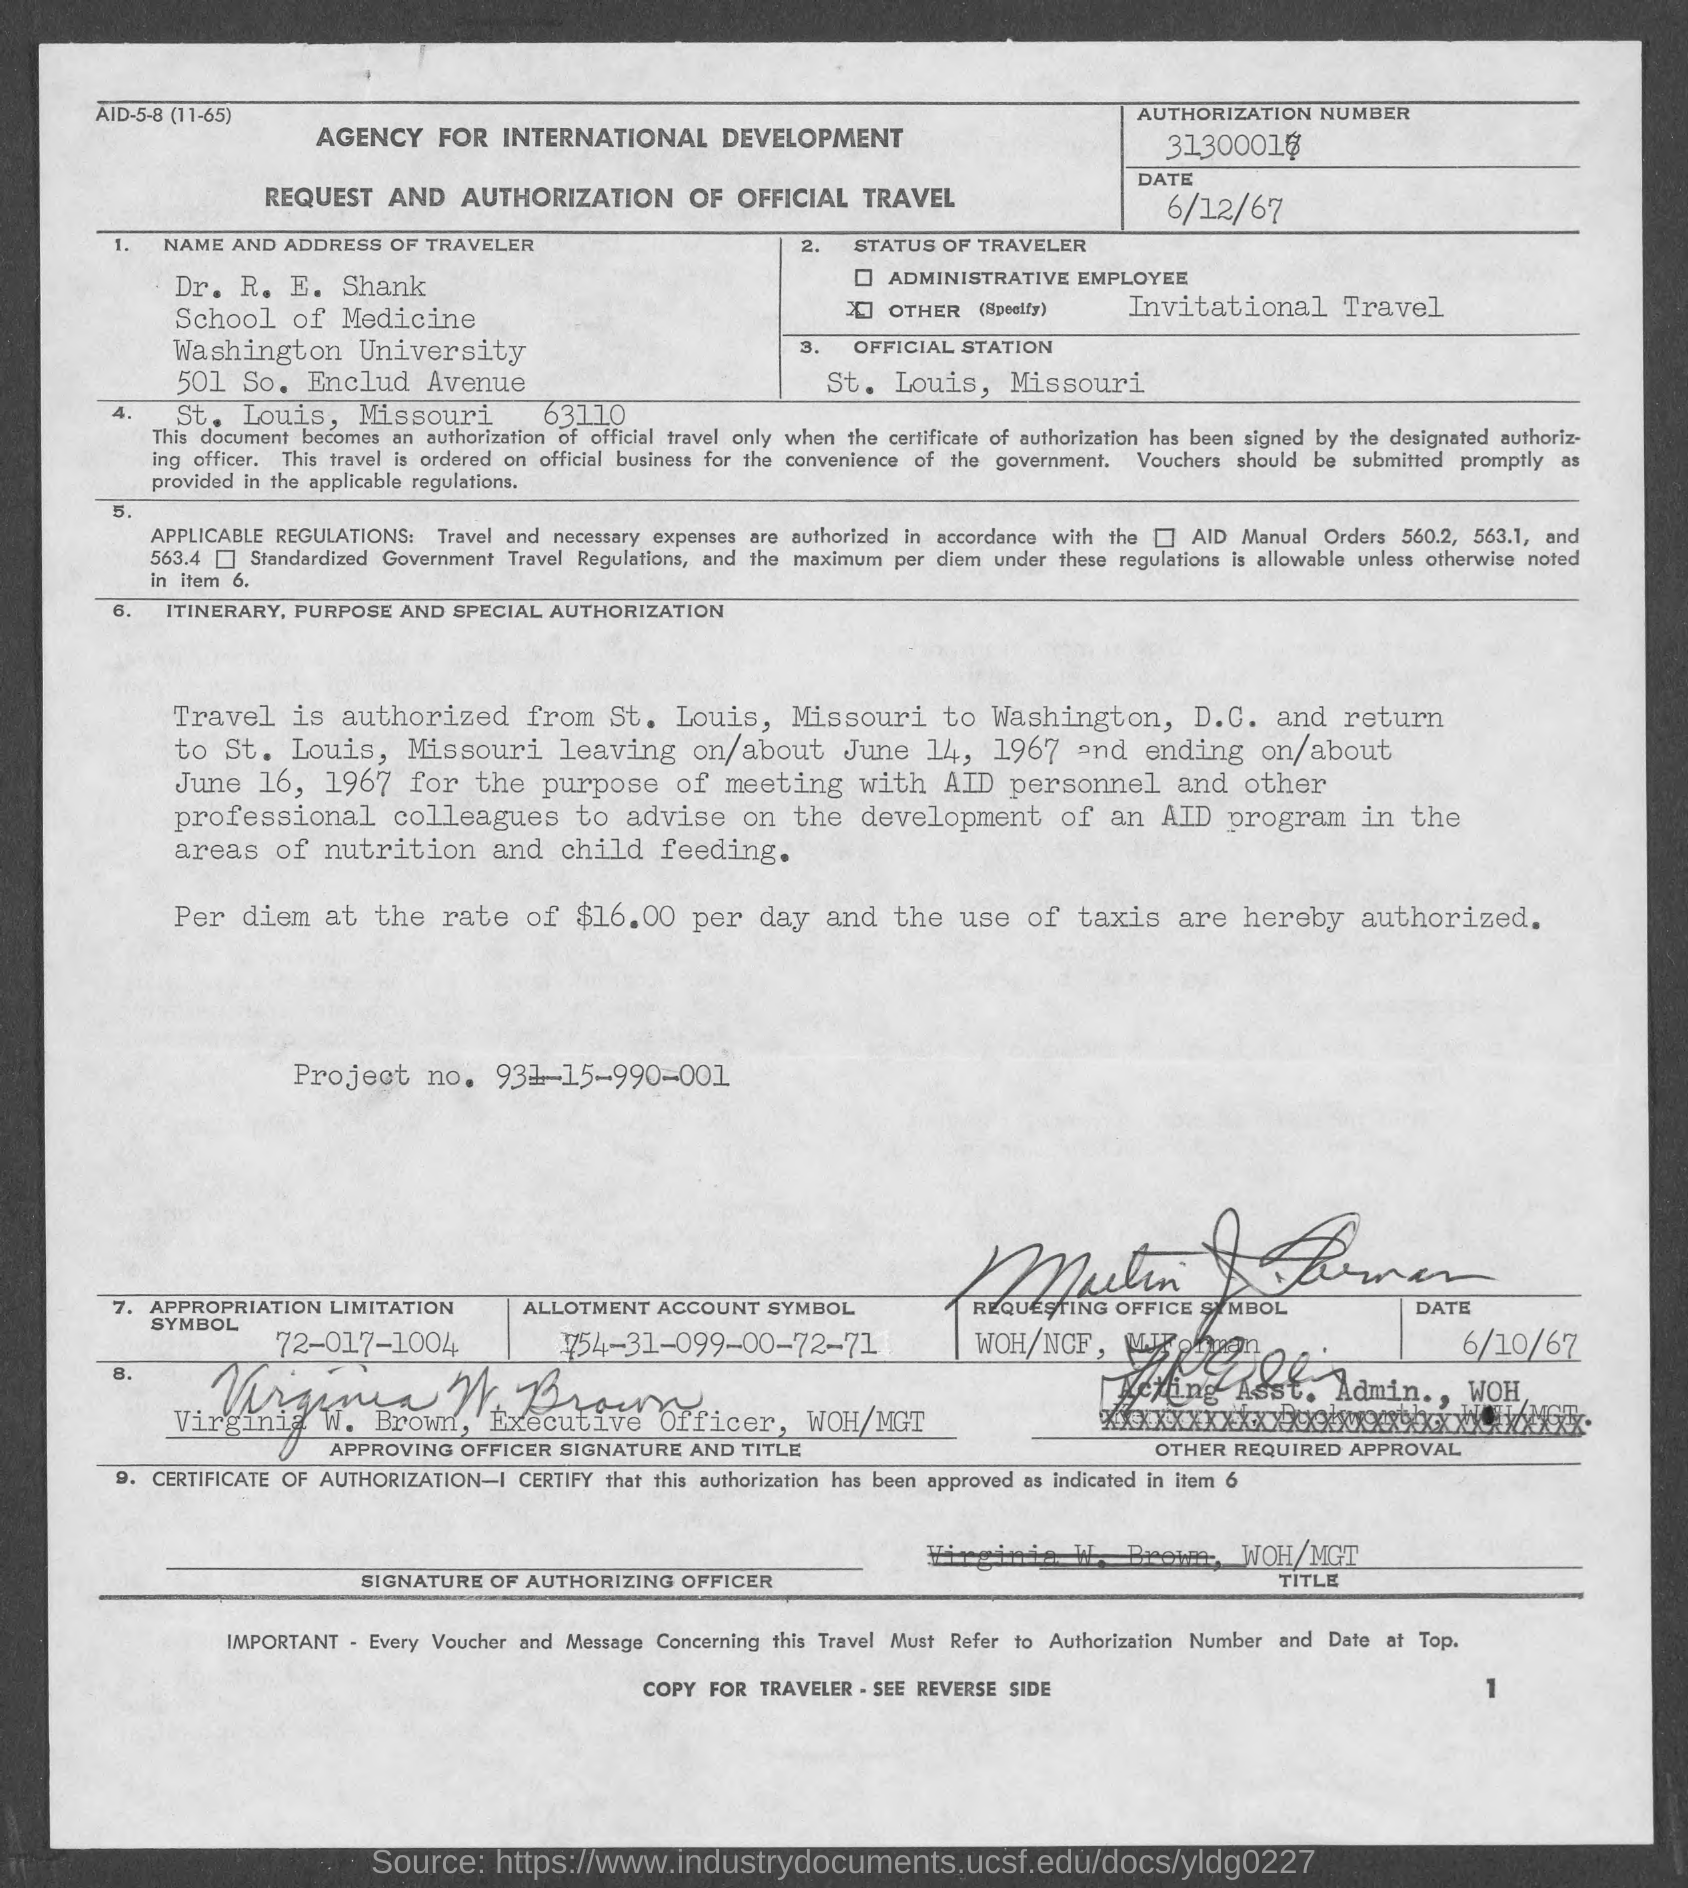What is the name of the traveler ?
Your answer should be compact. Dr. R. E. Shank. What is the official station ?
Provide a short and direct response. St. Louis, Missouri. What is the status of traveler ?
Provide a succinct answer. Invitational Travel. Who is the executive officer, woh/mgt ?
Your answer should be compact. Virginia W. Brown. What is the appropriation limitation symbol ?
Provide a succinct answer. 72-017-1004. What is the allotment account symbol ?
Ensure brevity in your answer.  1754-31-099-00-72-71. What is the project no.?
Offer a very short reply. 931-15-990-001. 